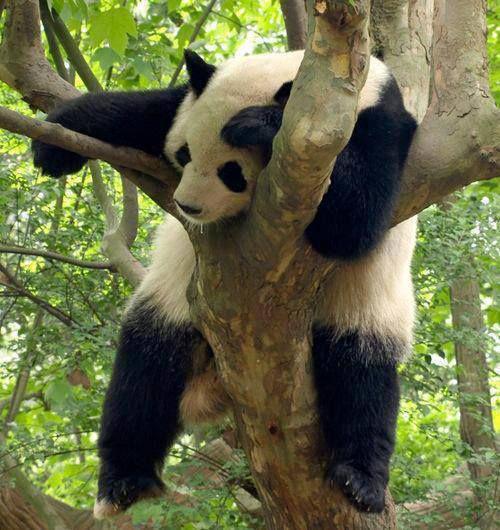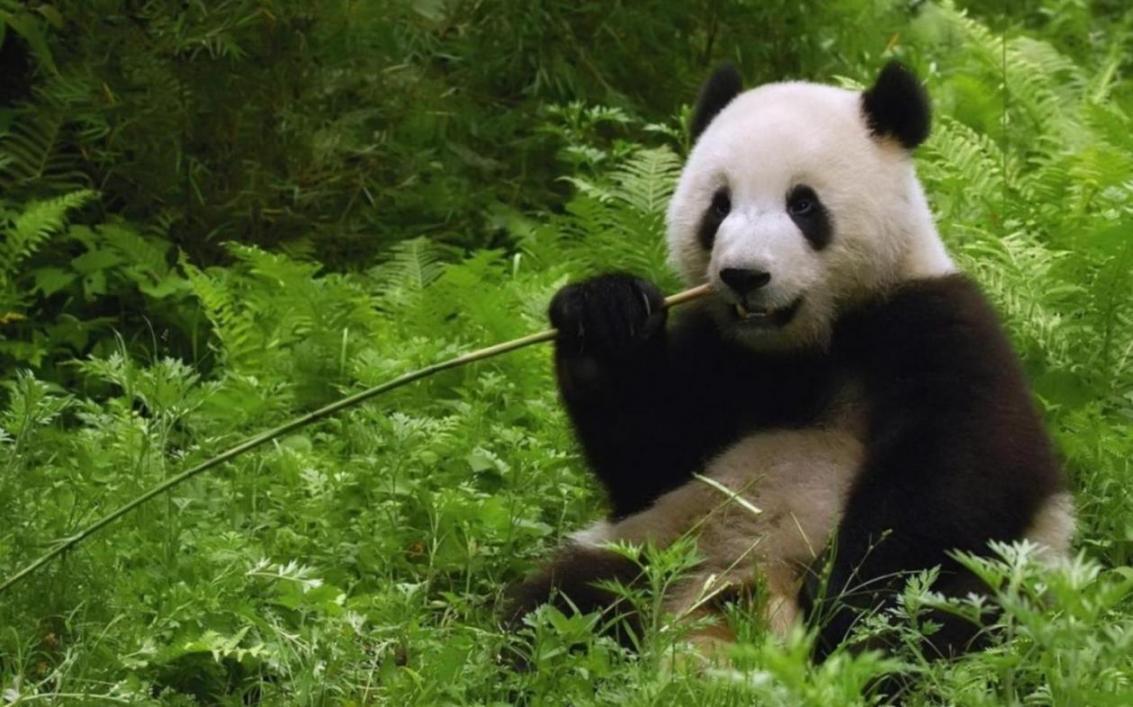The first image is the image on the left, the second image is the image on the right. Examine the images to the left and right. Is the description "There is a panda lounging against a brown tree in one of the images." accurate? Answer yes or no. Yes. The first image is the image on the left, the second image is the image on the right. Examine the images to the left and right. Is the description "a panda is laying belly down on a tree limb" accurate? Answer yes or no. Yes. 